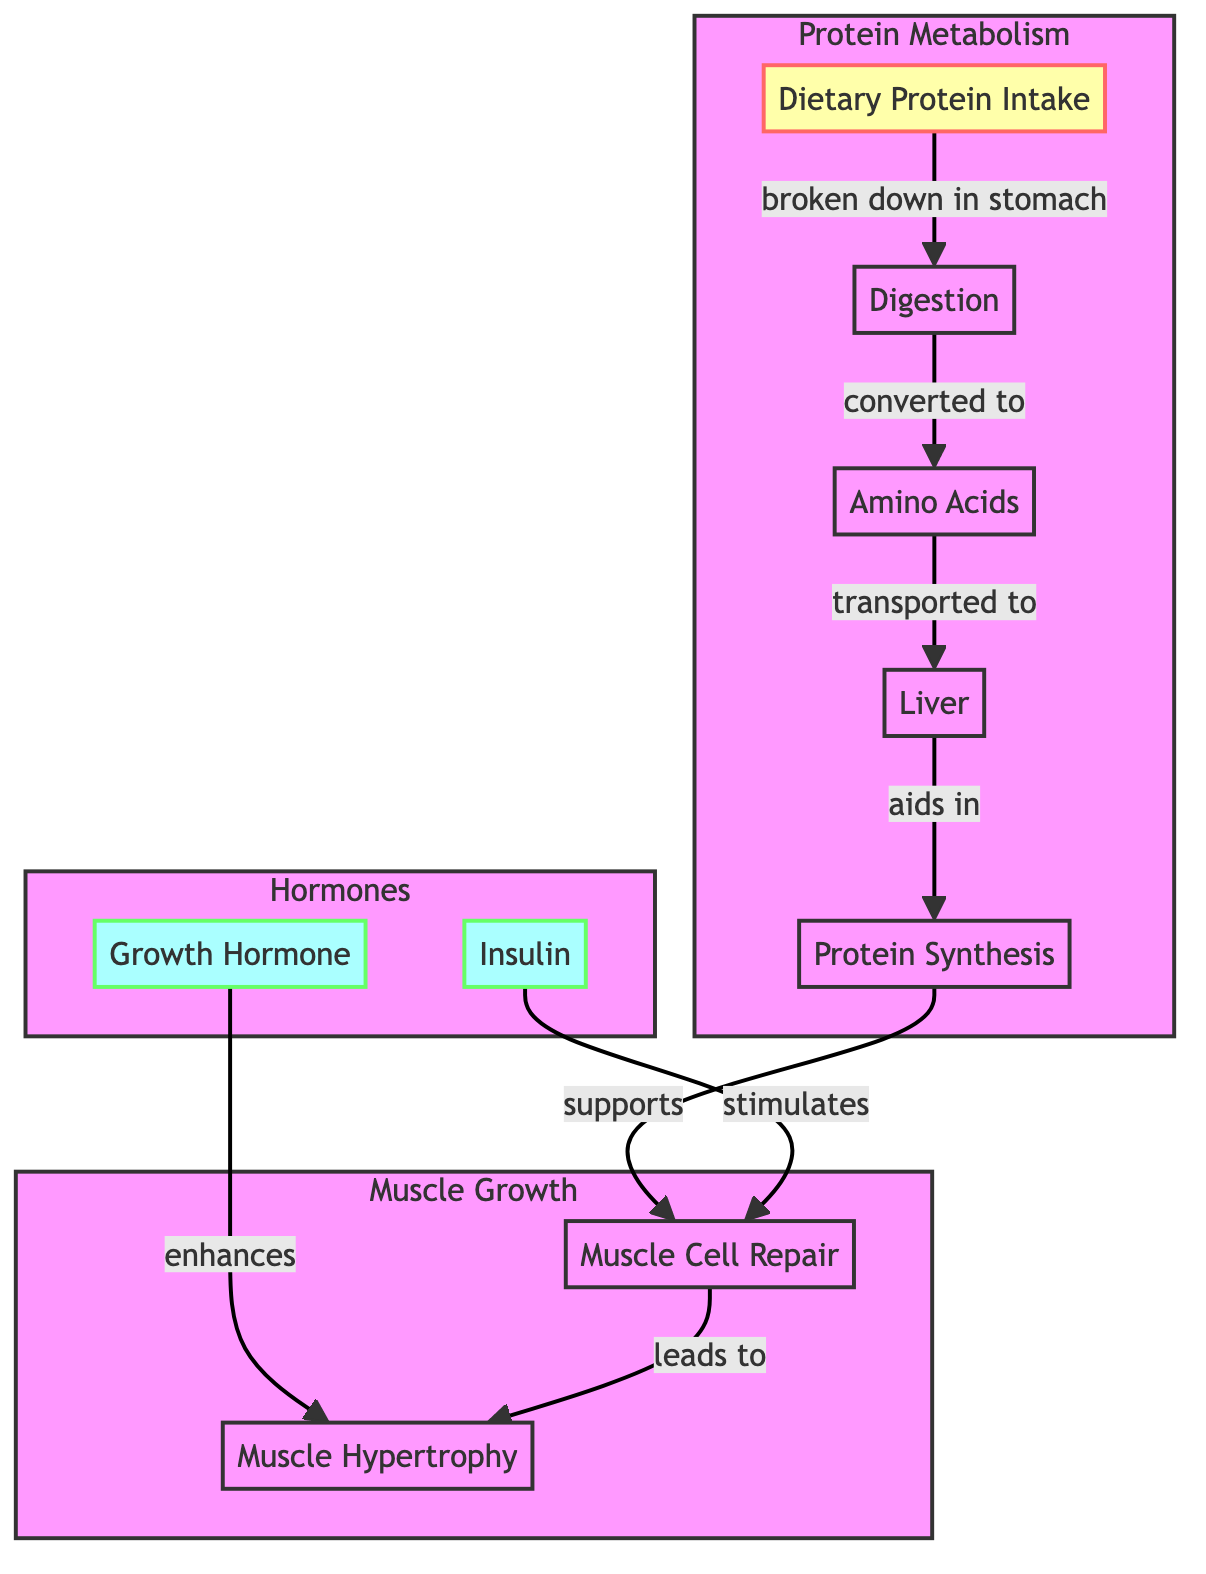What is the first step in the process after dietary protein intake? The diagram indicates that the first step after dietary protein intake is "Digestion," as it shows an arrow from "Dietary Protein Intake" to "Digestion."
Answer: Digestion Which substance is formed after the digestion of dietary protein? The diagram shows that after "Digestion," the next stage converts it to "Amino Acids," indicating that amino acids are formed from dietary protein.
Answer: Amino Acids How many hormonal influences are depicted in the diagram? By analyzing the Hormones subgraph, we can see there are two hormonal influences, "Insulin" and "Growth Hormone," clearly indicated in the diagram.
Answer: 2 What process supports muscle cell repair? The flow from "Protein Synthesis" to "Muscle Cell Repair" illustrates that protein synthesis is the process supporting muscle cell repair as shown in the diagram.
Answer: Protein Synthesis Which hormone stimulates muscle cell repair? The diagram specifies that "Insulin" is the hormone that stimulates "Muscle Cell Repair," indicating its role in this process.
Answer: Insulin What is the final outcome of muscle cell repair as indicated in the diagram? The diagram shows that "Muscle Cell Repair" leads to "Muscle Hypertrophy," establishing a direct relationship between these two nodes.
Answer: Muscle Hypertrophy Which organ aids in protein synthesis? According to the diagram, "Liver" is indicated to aid in "Protein Synthesis," establishing its role in this biological process.
Answer: Liver How does growth hormone affect muscle hypertrophy? The diagram establishes a direct link between "Growth Hormone" and "Muscle Hypertrophy," indicating that growth hormone enhances the process of muscle hypertrophy.
Answer: Enhances What does the subgraph "Protein Metabolism" include? The "Protein Metabolism" subgraph includes the elements: "Dietary Protein Intake," "Digestion," "Amino Acids," "Liver," and "Protein Synthesis," thus summarizing the key processes involved.
Answer: Dietary Protein Intake, Digestion, Amino Acids, Liver, Protein Synthesis 